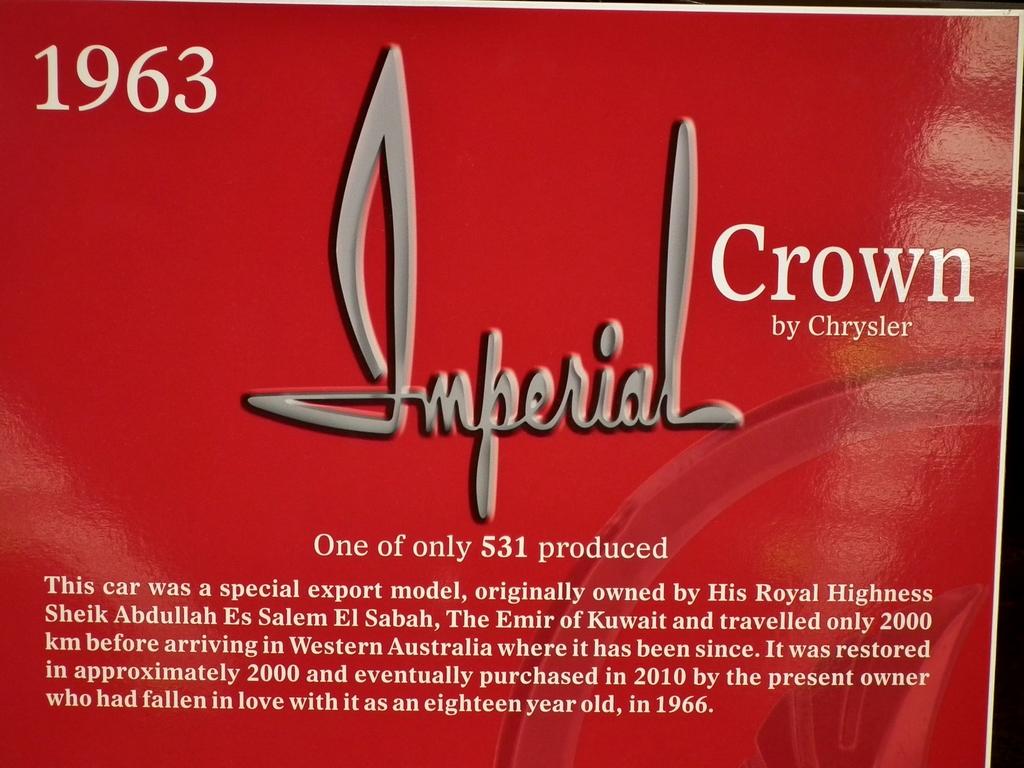Who makes crown?
Keep it short and to the point. Chrysler. What company produced this car?
Provide a short and direct response. Chrysler. 